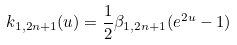<formula> <loc_0><loc_0><loc_500><loc_500>k _ { 1 , 2 n + 1 } ( u ) = \frac { 1 } { 2 } \beta _ { 1 , 2 n + 1 } ( e ^ { 2 u } - 1 )</formula> 